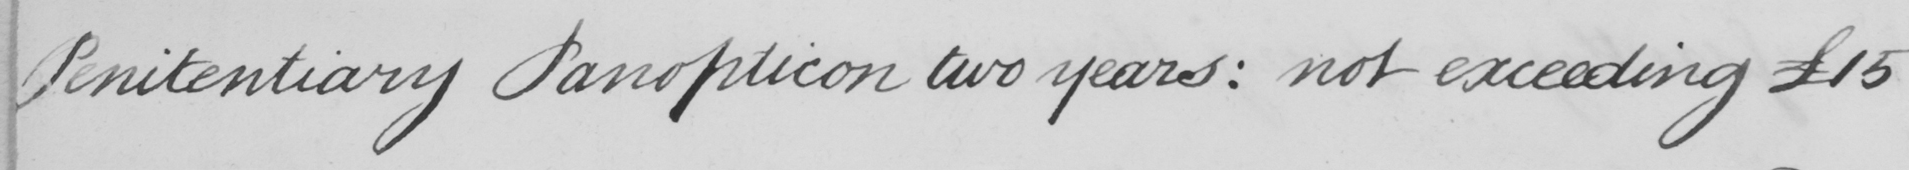Can you read and transcribe this handwriting? Penitentiary Panopticon two years :  not exceeding £15 